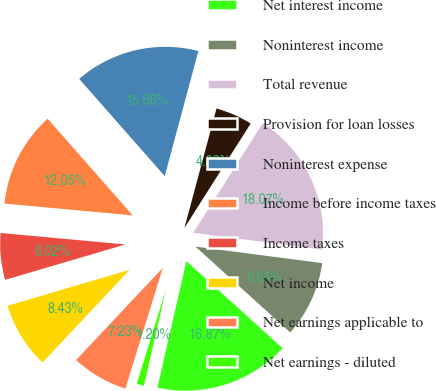Convert chart to OTSL. <chart><loc_0><loc_0><loc_500><loc_500><pie_chart><fcel>Net interest income<fcel>Noninterest income<fcel>Total revenue<fcel>Provision for loan losses<fcel>Noninterest expense<fcel>Income before income taxes<fcel>Income taxes<fcel>Net income<fcel>Net earnings applicable to<fcel>Net earnings - diluted<nl><fcel>16.87%<fcel>9.64%<fcel>18.07%<fcel>4.82%<fcel>15.66%<fcel>12.05%<fcel>6.02%<fcel>8.43%<fcel>7.23%<fcel>1.2%<nl></chart> 